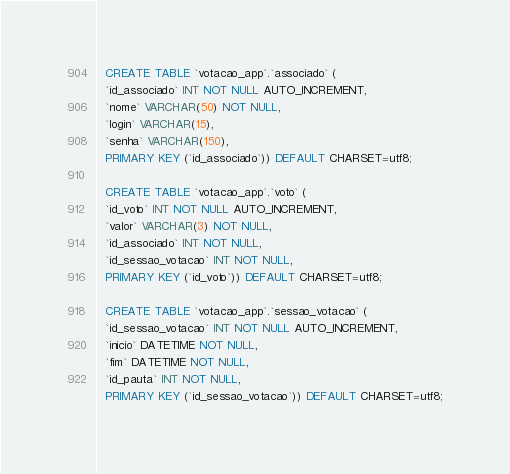Convert code to text. <code><loc_0><loc_0><loc_500><loc_500><_SQL_>  CREATE TABLE `votacao_app`.`associado` (
  `id_associado` INT NOT NULL AUTO_INCREMENT,
  `nome` VARCHAR(50) NOT NULL,
  `login` VARCHAR(15),
  `senha` VARCHAR(150),
  PRIMARY KEY (`id_associado`)) DEFAULT CHARSET=utf8;
  
  CREATE TABLE `votacao_app`.`voto` (
  `id_voto` INT NOT NULL AUTO_INCREMENT,
  `valor` VARCHAR(3) NOT NULL,
  `id_associado` INT NOT NULL,
  `id_sessao_votacao` INT NOT NULL,
  PRIMARY KEY (`id_voto`)) DEFAULT CHARSET=utf8;
  
  CREATE TABLE `votacao_app`.`sessao_votacao` (
  `id_sessao_votacao` INT NOT NULL AUTO_INCREMENT,
  `inicio` DATETIME NOT NULL,
  `fim` DATETIME NOT NULL,
  `id_pauta` INT NOT NULL,
  PRIMARY KEY (`id_sessao_votacao`)) DEFAULT CHARSET=utf8;</code> 